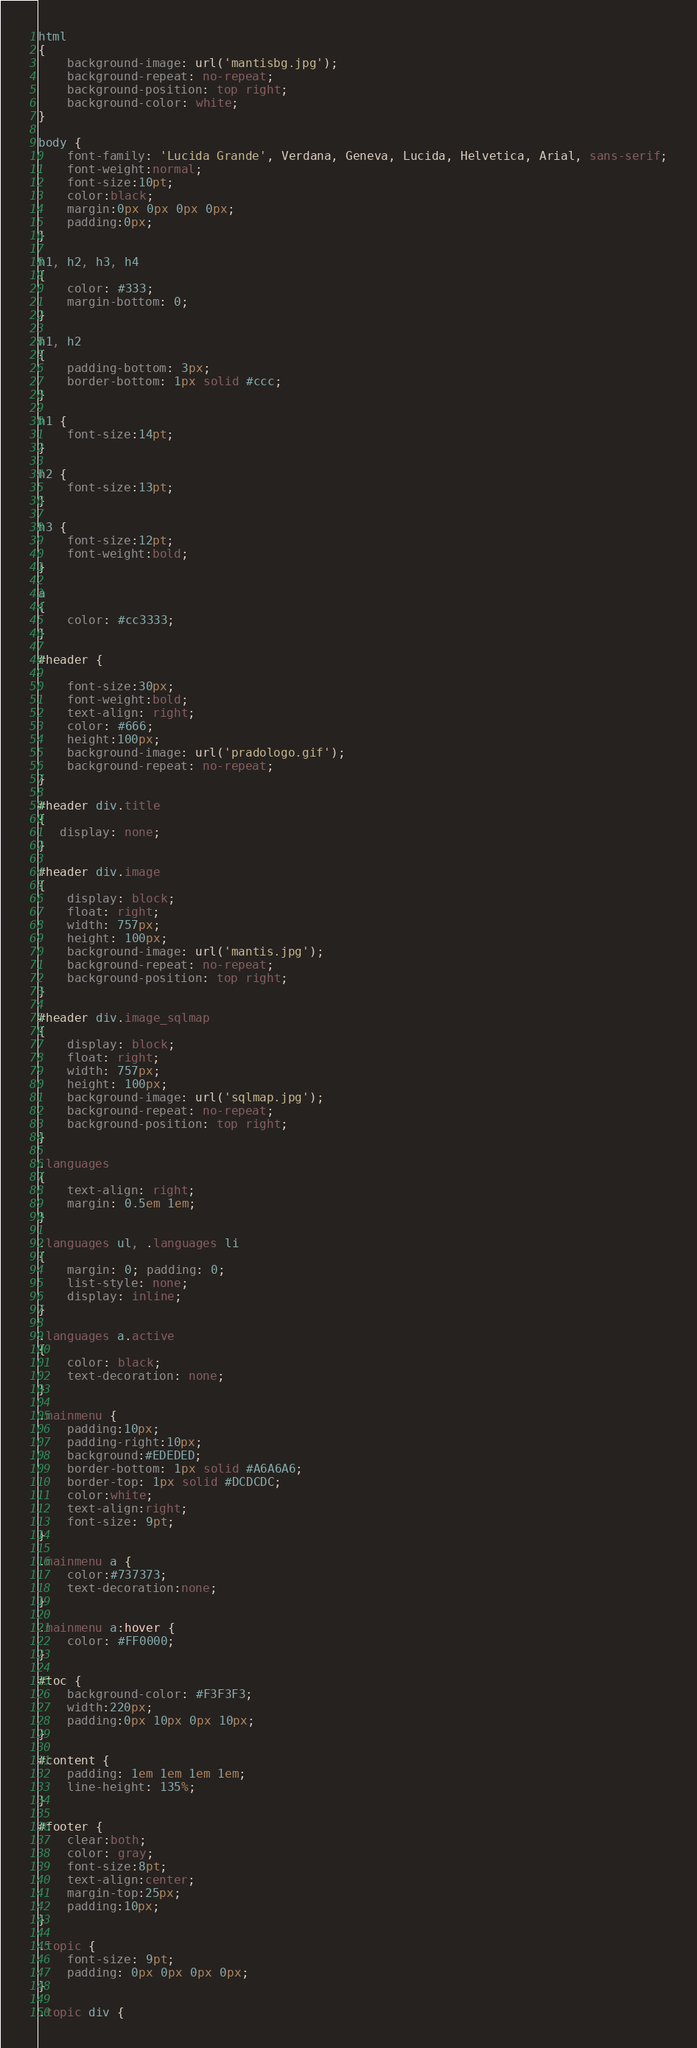<code> <loc_0><loc_0><loc_500><loc_500><_CSS_>html
{
	background-image: url('mantisbg.jpg');
	background-repeat: no-repeat;
	background-position: top right;
	background-color: white;
}

body {
	font-family: 'Lucida Grande', Verdana, Geneva, Lucida, Helvetica, Arial, sans-serif;
	font-weight:normal;
	font-size:10pt;
	color:black;
	margin:0px 0px 0px 0px;
	padding:0px;
}

h1, h2, h3, h4
{
	color: #333;
	margin-bottom: 0;
}

h1, h2
{
	padding-bottom: 3px;
	border-bottom: 1px solid #ccc;
}

h1 {
	font-size:14pt;
}

h2 {
	font-size:13pt;
}

h3 {
	font-size:12pt;
	font-weight:bold;
}

a
{
    color: #cc3333;
}

#header {

	font-size:30px;
	font-weight:bold;
	text-align: right;
	color: #666;
	height:100px;
	background-image: url('pradologo.gif');
	background-repeat: no-repeat;
}

#header div.title
{
   display: none;
}

#header div.image
{
    display: block;
    float: right;
    width: 757px;
    height: 100px;
    background-image: url('mantis.jpg');
    background-repeat: no-repeat;
    background-position: top right;
}

#header div.image_sqlmap
{
    display: block;
    float: right;
    width: 757px;
    height: 100px;
    background-image: url('sqlmap.jpg');
    background-repeat: no-repeat;
    background-position: top right;
}

.languages
{
	text-align: right;
	margin: 0.5em 1em;
}

.languages ul, .languages li
{
	margin: 0; padding: 0;
	list-style: none;
	display: inline;
}

.languages a.active
{
	color: black;
	text-decoration: none;
}

.mainmenu {
	padding:10px;
	padding-right:10px;
	background:#EDEDED;
	border-bottom: 1px solid #A6A6A6;
	border-top: 1px solid #DCDCDC;
	color:white;
	text-align:right;
	font-size: 9pt;
}

.mainmenu a {
	color:#737373;
	text-decoration:none;
}

.mainmenu a:hover {
	color: #FF0000;
}

#toc {
	background-color: #F3F3F3;
	width:220px;
	padding:0px 10px 0px 10px;
}

#content {
	padding: 1em 1em 1em 1em;
	line-height: 135%;
}

#footer {
	clear:both;
	color: gray;
	font-size:8pt;
	text-align:center;
	margin-top:25px;
	padding:10px;
}

.topic {
	font-size: 9pt;
	padding: 0px 0px 0px 0px;
}

.topic div {</code> 